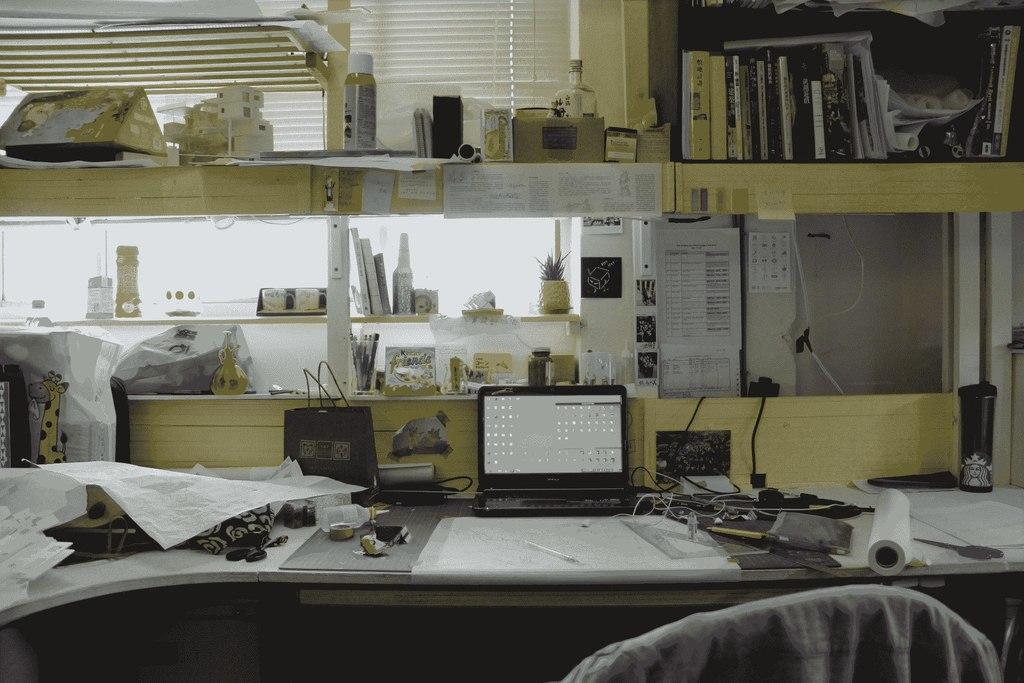Can you describe this image briefly? In this picture there is a laptop, bottle, bag, books, plant ,sheet and few objects. There is a chair. 